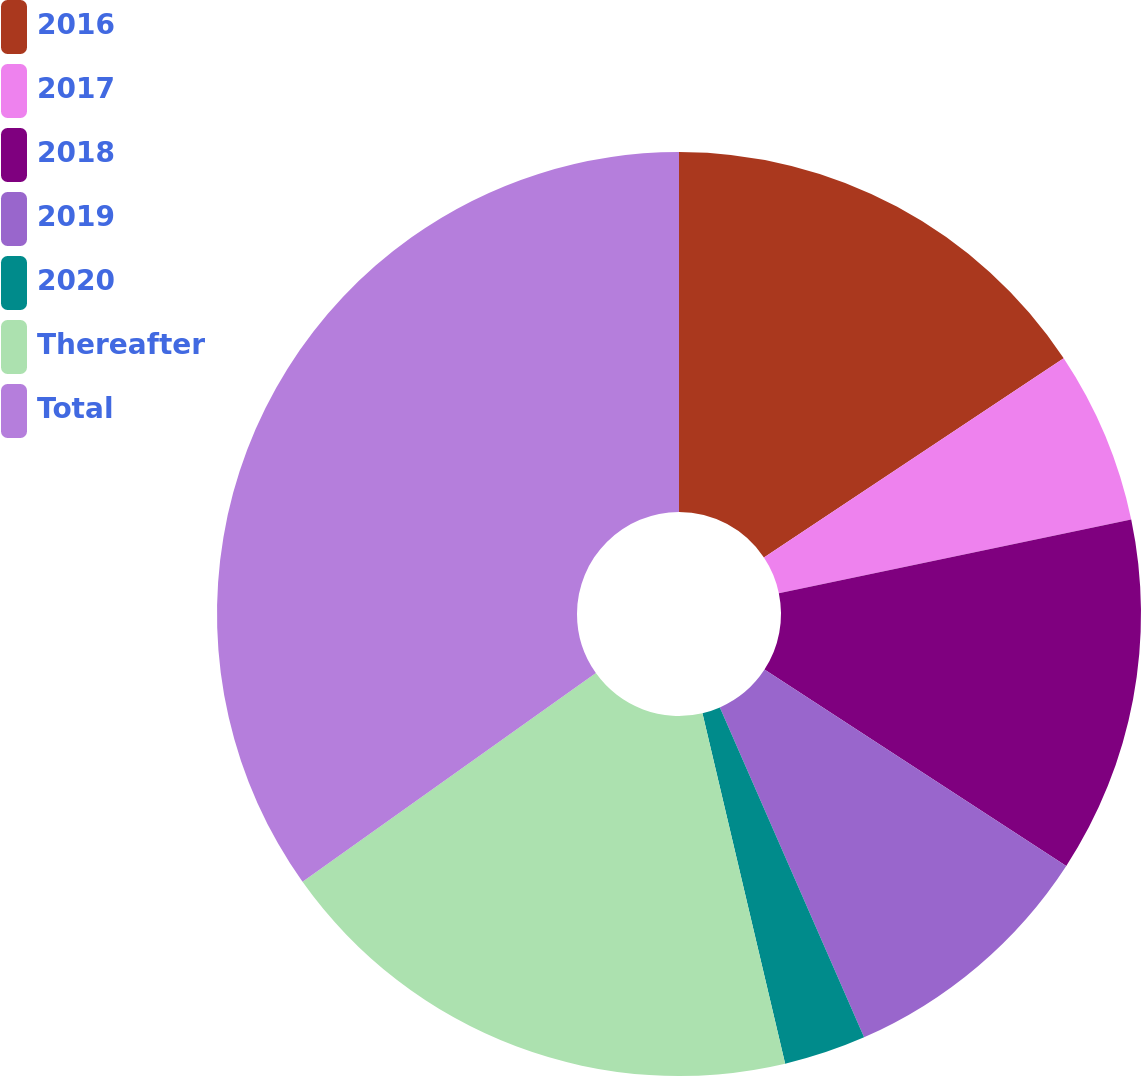Convert chart to OTSL. <chart><loc_0><loc_0><loc_500><loc_500><pie_chart><fcel>2016<fcel>2017<fcel>2018<fcel>2019<fcel>2020<fcel>Thereafter<fcel>Total<nl><fcel>15.66%<fcel>6.06%<fcel>12.46%<fcel>9.26%<fcel>2.87%<fcel>18.85%<fcel>34.84%<nl></chart> 